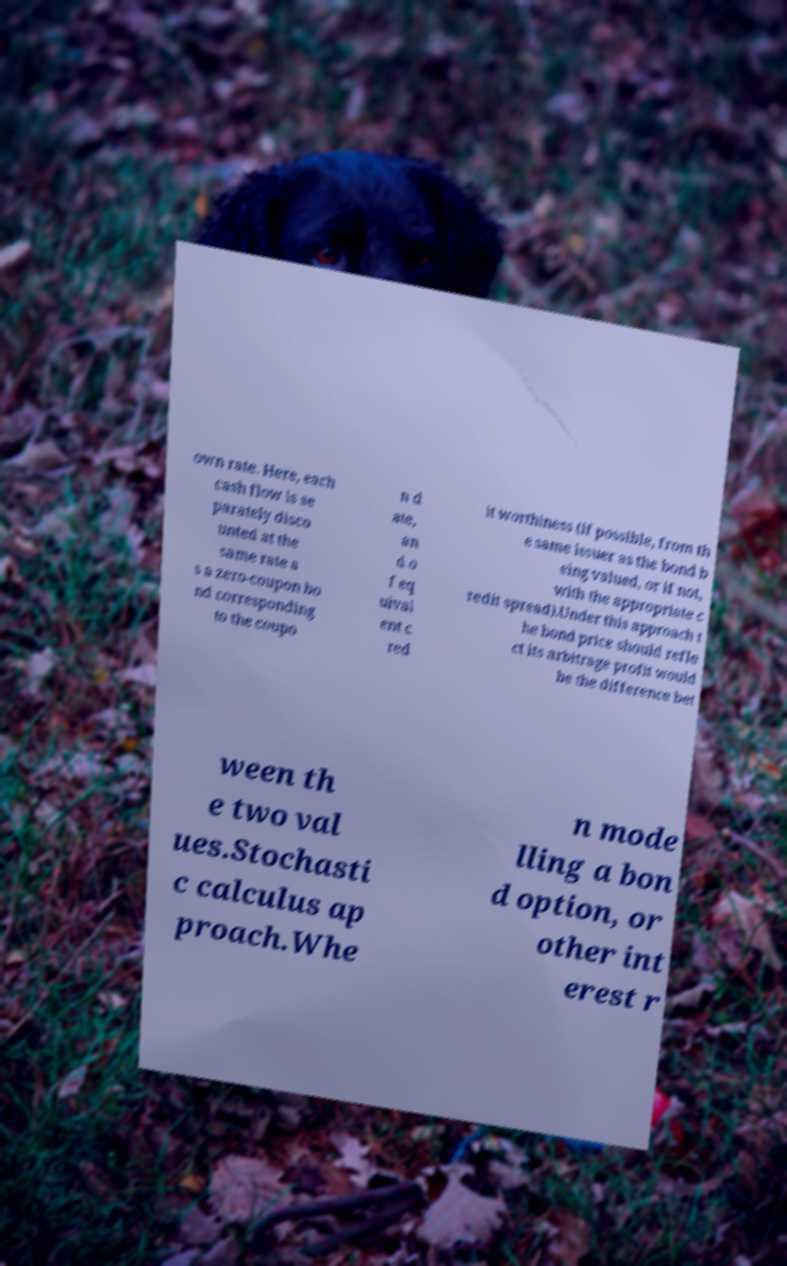I need the written content from this picture converted into text. Can you do that? own rate. Here, each cash flow is se parately disco unted at the same rate a s a zero-coupon bo nd corresponding to the coupo n d ate, an d o f eq uival ent c red it worthiness (if possible, from th e same issuer as the bond b eing valued, or if not, with the appropriate c redit spread).Under this approach t he bond price should refle ct its arbitrage profit would be the difference bet ween th e two val ues.Stochasti c calculus ap proach.Whe n mode lling a bon d option, or other int erest r 